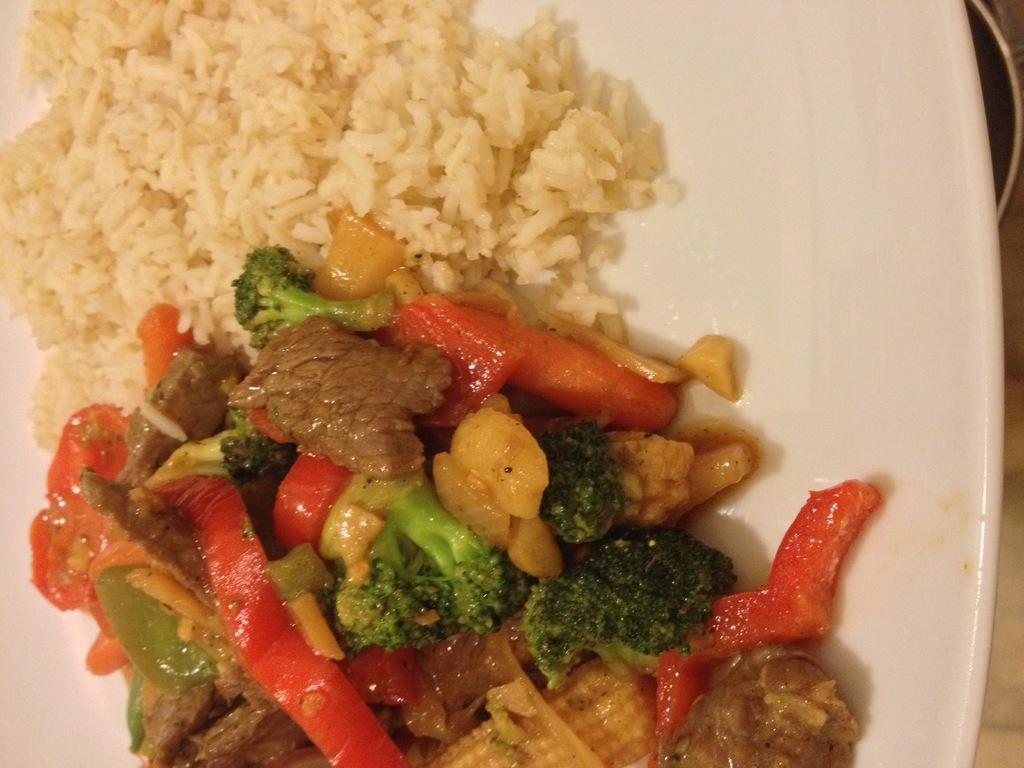Could you give a brief overview of what you see in this image? In this image, we can see food on the plate and at the bottom, there is table and a bowl. 